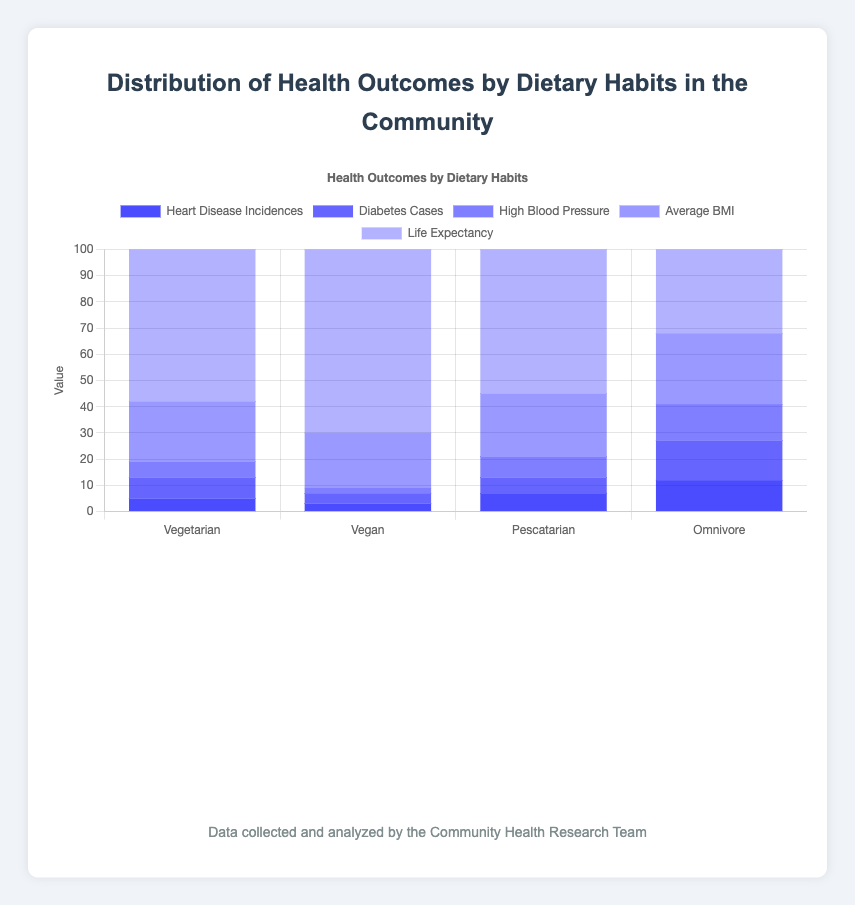What dietary habit has the lowest average BMI? The figure shows the average BMI for each dietary habit: Vegetarian (23), Vegan (21), Pescatarian (24), and Omnivore (27). The lowest average BMI among these is for Vegans.
Answer: Vegan Which dietary group has the highest life expectancy? The figure lists the life expectancy for each dietary habit: Vegetarian (81), Vegan (85), Pescatarian (79), and Omnivore (76). The highest life expectancy is in the Vegan group.
Answer: Vegan By how much do heart disease incidences in Omnivores exceed those in Vegans? Heart disease incidences are 12 for Omnivores and 3 for Vegans. The difference is 12 - 3.
Answer: 9 How does the number of diabetes cases in Pescatarians compare to the number in Vegetarians? Diabetes cases for Pescatarians are 6 and for Vegetarians are 8. 6 is less than 8.
Answer: Less What is the average life expectancy across all dietary habits? Add the life expectancy values (81 for Vegetarian, 85 for Vegan, 79 for Pescatarian, and 76 for Omnivore), then divide by the number of groups: (81 + 85 + 79 + 76) / 4.
Answer: 80.25 How do the incidences of high blood pressure compare between Vegetarians and Omnivores? High blood pressure cases for Vegetarians are 6 and for Omnivores are 14. 6 is less than 14.
Answer: Less What is the difference in average BMI between Pescatarians and Omnivores? The average BMI is 24 for Pescatarians and 27 for Omnivores. The difference is 27 - 24.
Answer: 3 Which dietary habit group has the highest number of total health issues mentioned in the figure? Sum the incidences of heart disease, diabetes, and high blood pressure for each dietary group. The totals are: Vegetarian (5+8+6=19), Vegan (3+4+2=9), Pescatarian (7+6+8=21), and Omnivore (12+15+14=41). The highest number of total health issues is in Omnivores.
Answer: Omnivore 